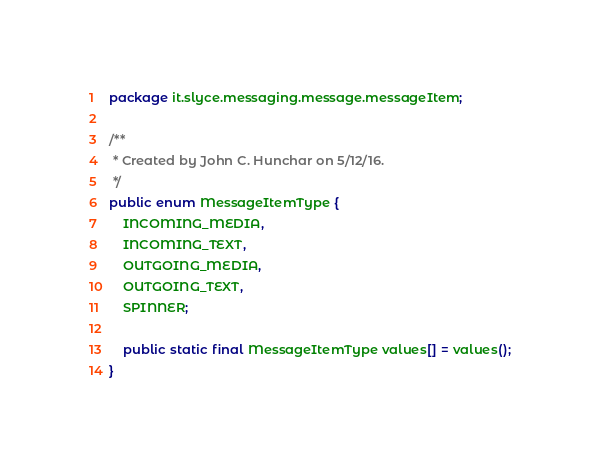<code> <loc_0><loc_0><loc_500><loc_500><_Java_>package it.slyce.messaging.message.messageItem;

/**
 * Created by John C. Hunchar on 5/12/16.
 */
public enum MessageItemType {
    INCOMING_MEDIA,
    INCOMING_TEXT,
    OUTGOING_MEDIA,
    OUTGOING_TEXT,
    SPINNER;

    public static final MessageItemType values[] = values();
}
</code> 